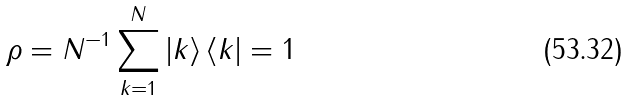Convert formula to latex. <formula><loc_0><loc_0><loc_500><loc_500>\rho = N ^ { - 1 } \sum _ { k = 1 } ^ { N } \left | k \right > \left < k \right | = { 1 }</formula> 